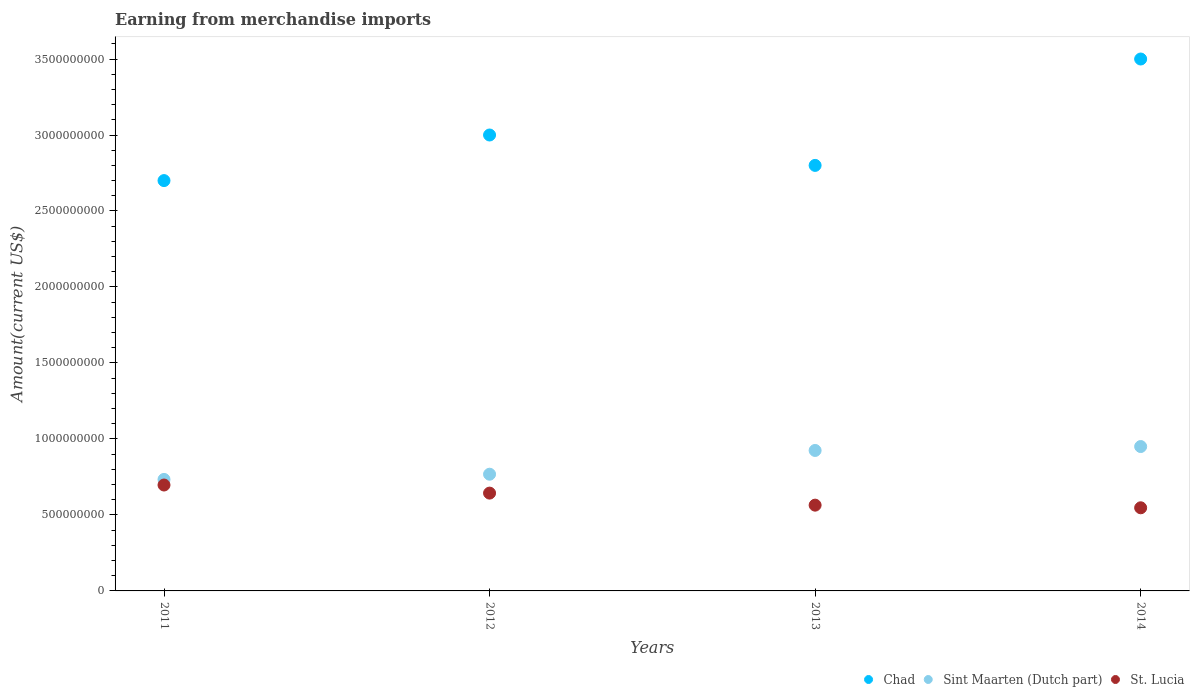How many different coloured dotlines are there?
Offer a terse response. 3. What is the amount earned from merchandise imports in Sint Maarten (Dutch part) in 2012?
Your response must be concise. 7.68e+08. Across all years, what is the maximum amount earned from merchandise imports in Chad?
Your answer should be very brief. 3.50e+09. Across all years, what is the minimum amount earned from merchandise imports in Chad?
Your answer should be compact. 2.70e+09. In which year was the amount earned from merchandise imports in Sint Maarten (Dutch part) maximum?
Your answer should be compact. 2014. What is the total amount earned from merchandise imports in St. Lucia in the graph?
Keep it short and to the point. 2.45e+09. What is the difference between the amount earned from merchandise imports in Chad in 2013 and that in 2014?
Ensure brevity in your answer.  -7.00e+08. What is the difference between the amount earned from merchandise imports in Sint Maarten (Dutch part) in 2013 and the amount earned from merchandise imports in Chad in 2014?
Keep it short and to the point. -2.58e+09. What is the average amount earned from merchandise imports in Sint Maarten (Dutch part) per year?
Offer a terse response. 8.44e+08. In the year 2012, what is the difference between the amount earned from merchandise imports in St. Lucia and amount earned from merchandise imports in Sint Maarten (Dutch part)?
Your response must be concise. -1.24e+08. What is the ratio of the amount earned from merchandise imports in Chad in 2011 to that in 2014?
Keep it short and to the point. 0.77. Is the amount earned from merchandise imports in Chad in 2011 less than that in 2013?
Give a very brief answer. Yes. What is the difference between the highest and the second highest amount earned from merchandise imports in St. Lucia?
Your answer should be very brief. 5.33e+07. What is the difference between the highest and the lowest amount earned from merchandise imports in Chad?
Provide a succinct answer. 8.00e+08. Is the sum of the amount earned from merchandise imports in Sint Maarten (Dutch part) in 2012 and 2014 greater than the maximum amount earned from merchandise imports in Chad across all years?
Provide a short and direct response. No. Does the amount earned from merchandise imports in St. Lucia monotonically increase over the years?
Ensure brevity in your answer.  No. Is the amount earned from merchandise imports in St. Lucia strictly greater than the amount earned from merchandise imports in Sint Maarten (Dutch part) over the years?
Your answer should be very brief. No. Is the amount earned from merchandise imports in St. Lucia strictly less than the amount earned from merchandise imports in Chad over the years?
Keep it short and to the point. Yes. What is the difference between two consecutive major ticks on the Y-axis?
Offer a terse response. 5.00e+08. Are the values on the major ticks of Y-axis written in scientific E-notation?
Offer a very short reply. No. How many legend labels are there?
Give a very brief answer. 3. How are the legend labels stacked?
Your response must be concise. Horizontal. What is the title of the graph?
Provide a short and direct response. Earning from merchandise imports. What is the label or title of the X-axis?
Offer a terse response. Years. What is the label or title of the Y-axis?
Offer a terse response. Amount(current US$). What is the Amount(current US$) in Chad in 2011?
Provide a succinct answer. 2.70e+09. What is the Amount(current US$) of Sint Maarten (Dutch part) in 2011?
Make the answer very short. 7.34e+08. What is the Amount(current US$) in St. Lucia in 2011?
Provide a succinct answer. 6.97e+08. What is the Amount(current US$) of Chad in 2012?
Your answer should be very brief. 3.00e+09. What is the Amount(current US$) of Sint Maarten (Dutch part) in 2012?
Give a very brief answer. 7.68e+08. What is the Amount(current US$) of St. Lucia in 2012?
Ensure brevity in your answer.  6.44e+08. What is the Amount(current US$) in Chad in 2013?
Your response must be concise. 2.80e+09. What is the Amount(current US$) of Sint Maarten (Dutch part) in 2013?
Provide a succinct answer. 9.24e+08. What is the Amount(current US$) of St. Lucia in 2013?
Offer a very short reply. 5.64e+08. What is the Amount(current US$) in Chad in 2014?
Provide a short and direct response. 3.50e+09. What is the Amount(current US$) in Sint Maarten (Dutch part) in 2014?
Keep it short and to the point. 9.50e+08. What is the Amount(current US$) in St. Lucia in 2014?
Make the answer very short. 5.47e+08. Across all years, what is the maximum Amount(current US$) in Chad?
Your response must be concise. 3.50e+09. Across all years, what is the maximum Amount(current US$) in Sint Maarten (Dutch part)?
Provide a succinct answer. 9.50e+08. Across all years, what is the maximum Amount(current US$) in St. Lucia?
Give a very brief answer. 6.97e+08. Across all years, what is the minimum Amount(current US$) of Chad?
Your answer should be compact. 2.70e+09. Across all years, what is the minimum Amount(current US$) in Sint Maarten (Dutch part)?
Make the answer very short. 7.34e+08. Across all years, what is the minimum Amount(current US$) of St. Lucia?
Your answer should be compact. 5.47e+08. What is the total Amount(current US$) in Chad in the graph?
Provide a short and direct response. 1.20e+1. What is the total Amount(current US$) of Sint Maarten (Dutch part) in the graph?
Offer a very short reply. 3.38e+09. What is the total Amount(current US$) in St. Lucia in the graph?
Offer a very short reply. 2.45e+09. What is the difference between the Amount(current US$) in Chad in 2011 and that in 2012?
Offer a very short reply. -3.00e+08. What is the difference between the Amount(current US$) in Sint Maarten (Dutch part) in 2011 and that in 2012?
Your response must be concise. -3.43e+07. What is the difference between the Amount(current US$) of St. Lucia in 2011 and that in 2012?
Your answer should be very brief. 5.33e+07. What is the difference between the Amount(current US$) of Chad in 2011 and that in 2013?
Ensure brevity in your answer.  -1.00e+08. What is the difference between the Amount(current US$) in Sint Maarten (Dutch part) in 2011 and that in 2013?
Provide a succinct answer. -1.91e+08. What is the difference between the Amount(current US$) in St. Lucia in 2011 and that in 2013?
Your answer should be very brief. 1.32e+08. What is the difference between the Amount(current US$) of Chad in 2011 and that in 2014?
Provide a short and direct response. -8.00e+08. What is the difference between the Amount(current US$) of Sint Maarten (Dutch part) in 2011 and that in 2014?
Your response must be concise. -2.16e+08. What is the difference between the Amount(current US$) in St. Lucia in 2011 and that in 2014?
Ensure brevity in your answer.  1.50e+08. What is the difference between the Amount(current US$) of Sint Maarten (Dutch part) in 2012 and that in 2013?
Your answer should be compact. -1.56e+08. What is the difference between the Amount(current US$) in St. Lucia in 2012 and that in 2013?
Give a very brief answer. 7.92e+07. What is the difference between the Amount(current US$) in Chad in 2012 and that in 2014?
Give a very brief answer. -5.00e+08. What is the difference between the Amount(current US$) of Sint Maarten (Dutch part) in 2012 and that in 2014?
Provide a succinct answer. -1.82e+08. What is the difference between the Amount(current US$) in St. Lucia in 2012 and that in 2014?
Provide a succinct answer. 9.66e+07. What is the difference between the Amount(current US$) in Chad in 2013 and that in 2014?
Make the answer very short. -7.00e+08. What is the difference between the Amount(current US$) of Sint Maarten (Dutch part) in 2013 and that in 2014?
Your answer should be compact. -2.58e+07. What is the difference between the Amount(current US$) in St. Lucia in 2013 and that in 2014?
Give a very brief answer. 1.74e+07. What is the difference between the Amount(current US$) in Chad in 2011 and the Amount(current US$) in Sint Maarten (Dutch part) in 2012?
Offer a terse response. 1.93e+09. What is the difference between the Amount(current US$) of Chad in 2011 and the Amount(current US$) of St. Lucia in 2012?
Offer a terse response. 2.06e+09. What is the difference between the Amount(current US$) of Sint Maarten (Dutch part) in 2011 and the Amount(current US$) of St. Lucia in 2012?
Your response must be concise. 9.00e+07. What is the difference between the Amount(current US$) of Chad in 2011 and the Amount(current US$) of Sint Maarten (Dutch part) in 2013?
Your response must be concise. 1.78e+09. What is the difference between the Amount(current US$) of Chad in 2011 and the Amount(current US$) of St. Lucia in 2013?
Make the answer very short. 2.14e+09. What is the difference between the Amount(current US$) of Sint Maarten (Dutch part) in 2011 and the Amount(current US$) of St. Lucia in 2013?
Give a very brief answer. 1.69e+08. What is the difference between the Amount(current US$) in Chad in 2011 and the Amount(current US$) in Sint Maarten (Dutch part) in 2014?
Offer a very short reply. 1.75e+09. What is the difference between the Amount(current US$) in Chad in 2011 and the Amount(current US$) in St. Lucia in 2014?
Your answer should be compact. 2.15e+09. What is the difference between the Amount(current US$) of Sint Maarten (Dutch part) in 2011 and the Amount(current US$) of St. Lucia in 2014?
Keep it short and to the point. 1.87e+08. What is the difference between the Amount(current US$) of Chad in 2012 and the Amount(current US$) of Sint Maarten (Dutch part) in 2013?
Give a very brief answer. 2.08e+09. What is the difference between the Amount(current US$) in Chad in 2012 and the Amount(current US$) in St. Lucia in 2013?
Your answer should be very brief. 2.44e+09. What is the difference between the Amount(current US$) of Sint Maarten (Dutch part) in 2012 and the Amount(current US$) of St. Lucia in 2013?
Provide a succinct answer. 2.04e+08. What is the difference between the Amount(current US$) in Chad in 2012 and the Amount(current US$) in Sint Maarten (Dutch part) in 2014?
Make the answer very short. 2.05e+09. What is the difference between the Amount(current US$) of Chad in 2012 and the Amount(current US$) of St. Lucia in 2014?
Keep it short and to the point. 2.45e+09. What is the difference between the Amount(current US$) of Sint Maarten (Dutch part) in 2012 and the Amount(current US$) of St. Lucia in 2014?
Make the answer very short. 2.21e+08. What is the difference between the Amount(current US$) in Chad in 2013 and the Amount(current US$) in Sint Maarten (Dutch part) in 2014?
Ensure brevity in your answer.  1.85e+09. What is the difference between the Amount(current US$) in Chad in 2013 and the Amount(current US$) in St. Lucia in 2014?
Provide a short and direct response. 2.25e+09. What is the difference between the Amount(current US$) of Sint Maarten (Dutch part) in 2013 and the Amount(current US$) of St. Lucia in 2014?
Offer a terse response. 3.77e+08. What is the average Amount(current US$) of Chad per year?
Ensure brevity in your answer.  3.00e+09. What is the average Amount(current US$) in Sint Maarten (Dutch part) per year?
Give a very brief answer. 8.44e+08. What is the average Amount(current US$) of St. Lucia per year?
Your answer should be very brief. 6.13e+08. In the year 2011, what is the difference between the Amount(current US$) in Chad and Amount(current US$) in Sint Maarten (Dutch part)?
Your answer should be very brief. 1.97e+09. In the year 2011, what is the difference between the Amount(current US$) in Chad and Amount(current US$) in St. Lucia?
Provide a succinct answer. 2.00e+09. In the year 2011, what is the difference between the Amount(current US$) in Sint Maarten (Dutch part) and Amount(current US$) in St. Lucia?
Your answer should be compact. 3.68e+07. In the year 2012, what is the difference between the Amount(current US$) of Chad and Amount(current US$) of Sint Maarten (Dutch part)?
Ensure brevity in your answer.  2.23e+09. In the year 2012, what is the difference between the Amount(current US$) of Chad and Amount(current US$) of St. Lucia?
Provide a short and direct response. 2.36e+09. In the year 2012, what is the difference between the Amount(current US$) in Sint Maarten (Dutch part) and Amount(current US$) in St. Lucia?
Make the answer very short. 1.24e+08. In the year 2013, what is the difference between the Amount(current US$) in Chad and Amount(current US$) in Sint Maarten (Dutch part)?
Keep it short and to the point. 1.88e+09. In the year 2013, what is the difference between the Amount(current US$) in Chad and Amount(current US$) in St. Lucia?
Your response must be concise. 2.24e+09. In the year 2013, what is the difference between the Amount(current US$) in Sint Maarten (Dutch part) and Amount(current US$) in St. Lucia?
Your answer should be compact. 3.60e+08. In the year 2014, what is the difference between the Amount(current US$) in Chad and Amount(current US$) in Sint Maarten (Dutch part)?
Give a very brief answer. 2.55e+09. In the year 2014, what is the difference between the Amount(current US$) of Chad and Amount(current US$) of St. Lucia?
Offer a very short reply. 2.95e+09. In the year 2014, what is the difference between the Amount(current US$) of Sint Maarten (Dutch part) and Amount(current US$) of St. Lucia?
Ensure brevity in your answer.  4.03e+08. What is the ratio of the Amount(current US$) in Sint Maarten (Dutch part) in 2011 to that in 2012?
Provide a succinct answer. 0.96. What is the ratio of the Amount(current US$) in St. Lucia in 2011 to that in 2012?
Keep it short and to the point. 1.08. What is the ratio of the Amount(current US$) of Chad in 2011 to that in 2013?
Make the answer very short. 0.96. What is the ratio of the Amount(current US$) of Sint Maarten (Dutch part) in 2011 to that in 2013?
Keep it short and to the point. 0.79. What is the ratio of the Amount(current US$) of St. Lucia in 2011 to that in 2013?
Offer a very short reply. 1.23. What is the ratio of the Amount(current US$) of Chad in 2011 to that in 2014?
Your answer should be very brief. 0.77. What is the ratio of the Amount(current US$) of Sint Maarten (Dutch part) in 2011 to that in 2014?
Your response must be concise. 0.77. What is the ratio of the Amount(current US$) of St. Lucia in 2011 to that in 2014?
Provide a short and direct response. 1.27. What is the ratio of the Amount(current US$) in Chad in 2012 to that in 2013?
Give a very brief answer. 1.07. What is the ratio of the Amount(current US$) in Sint Maarten (Dutch part) in 2012 to that in 2013?
Your answer should be very brief. 0.83. What is the ratio of the Amount(current US$) of St. Lucia in 2012 to that in 2013?
Your answer should be compact. 1.14. What is the ratio of the Amount(current US$) in Chad in 2012 to that in 2014?
Provide a short and direct response. 0.86. What is the ratio of the Amount(current US$) of Sint Maarten (Dutch part) in 2012 to that in 2014?
Offer a terse response. 0.81. What is the ratio of the Amount(current US$) of St. Lucia in 2012 to that in 2014?
Give a very brief answer. 1.18. What is the ratio of the Amount(current US$) in Sint Maarten (Dutch part) in 2013 to that in 2014?
Your answer should be compact. 0.97. What is the ratio of the Amount(current US$) of St. Lucia in 2013 to that in 2014?
Give a very brief answer. 1.03. What is the difference between the highest and the second highest Amount(current US$) in Sint Maarten (Dutch part)?
Your response must be concise. 2.58e+07. What is the difference between the highest and the second highest Amount(current US$) in St. Lucia?
Provide a succinct answer. 5.33e+07. What is the difference between the highest and the lowest Amount(current US$) of Chad?
Offer a very short reply. 8.00e+08. What is the difference between the highest and the lowest Amount(current US$) of Sint Maarten (Dutch part)?
Provide a succinct answer. 2.16e+08. What is the difference between the highest and the lowest Amount(current US$) in St. Lucia?
Your response must be concise. 1.50e+08. 